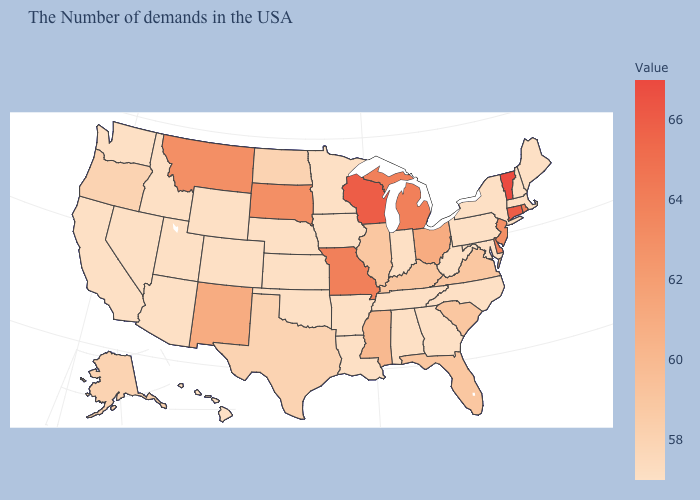Among the states that border Pennsylvania , which have the lowest value?
Short answer required. New York, Maryland, West Virginia. Among the states that border Illinois , does Kentucky have the lowest value?
Write a very short answer. No. Does Georgia have a higher value than Illinois?
Short answer required. No. Does New York have the lowest value in the USA?
Short answer required. Yes. 